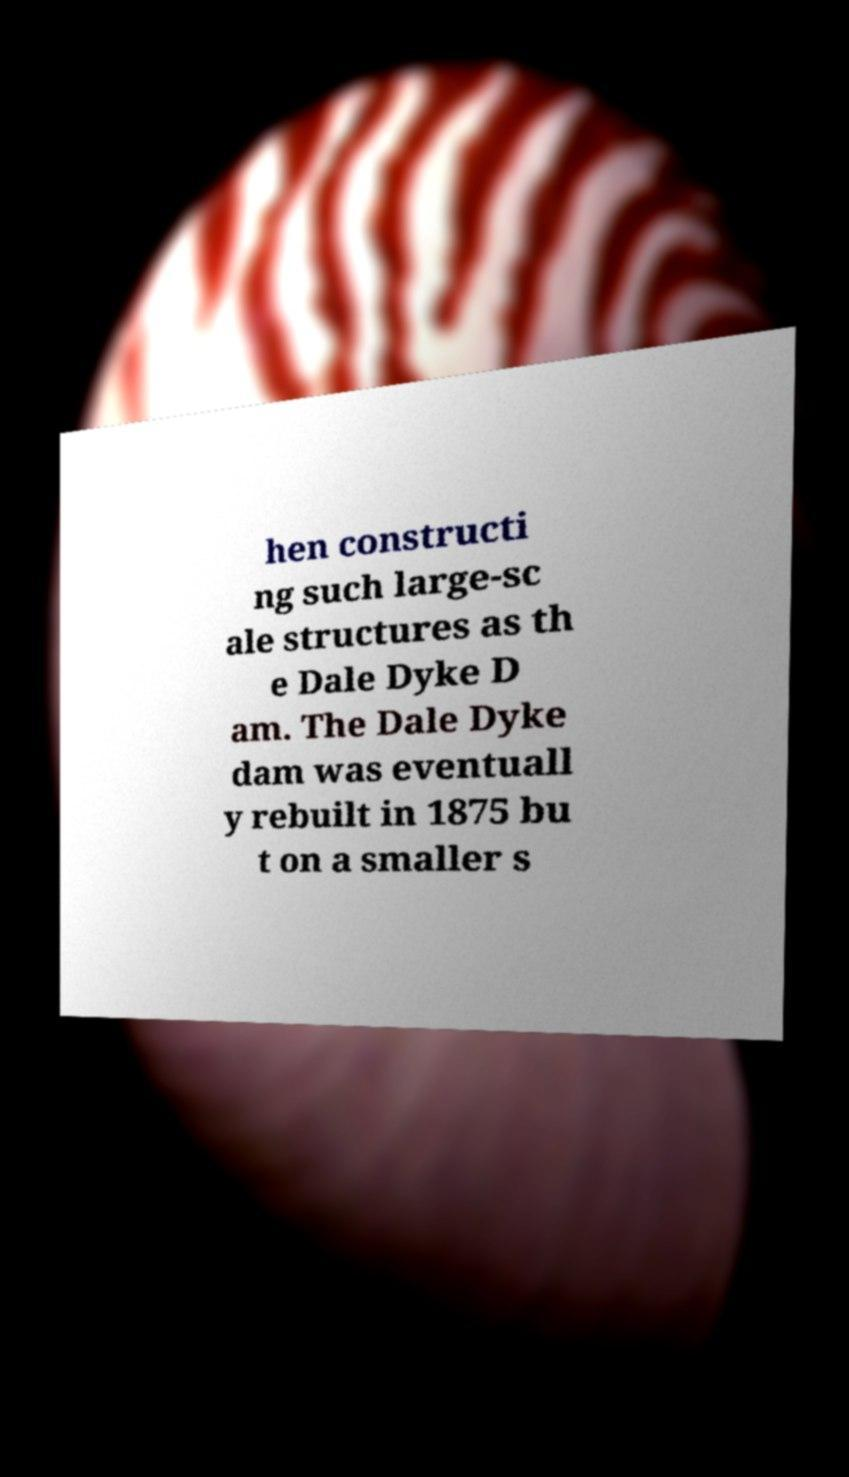There's text embedded in this image that I need extracted. Can you transcribe it verbatim? hen constructi ng such large-sc ale structures as th e Dale Dyke D am. The Dale Dyke dam was eventuall y rebuilt in 1875 bu t on a smaller s 